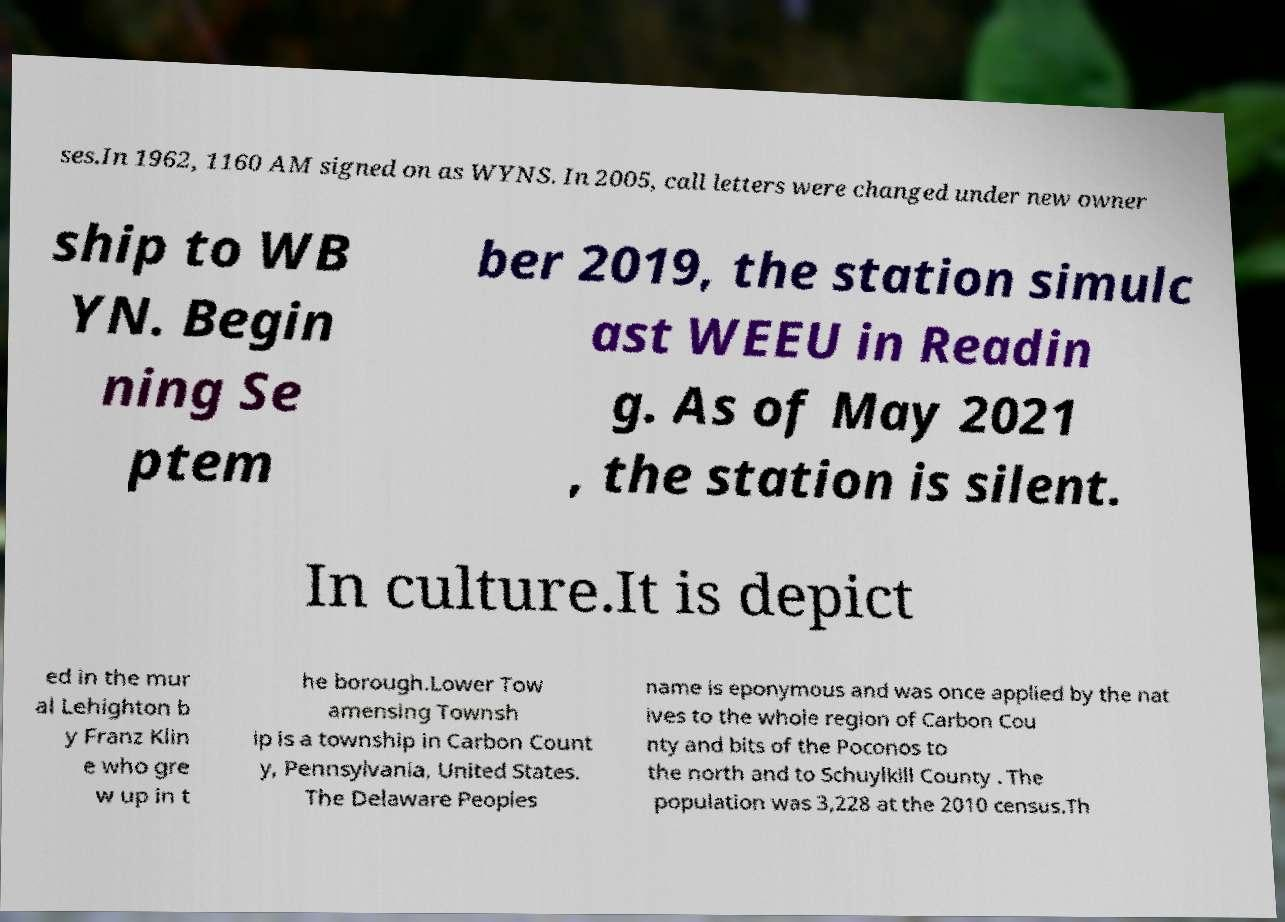What messages or text are displayed in this image? I need them in a readable, typed format. ses.In 1962, 1160 AM signed on as WYNS. In 2005, call letters were changed under new owner ship to WB YN. Begin ning Se ptem ber 2019, the station simulc ast WEEU in Readin g. As of May 2021 , the station is silent. In culture.It is depict ed in the mur al Lehighton b y Franz Klin e who gre w up in t he borough.Lower Tow amensing Townsh ip is a township in Carbon Count y, Pennsylvania, United States. The Delaware Peoples name is eponymous and was once applied by the nat ives to the whole region of Carbon Cou nty and bits of the Poconos to the north and to Schuylkill County . The population was 3,228 at the 2010 census.Th 